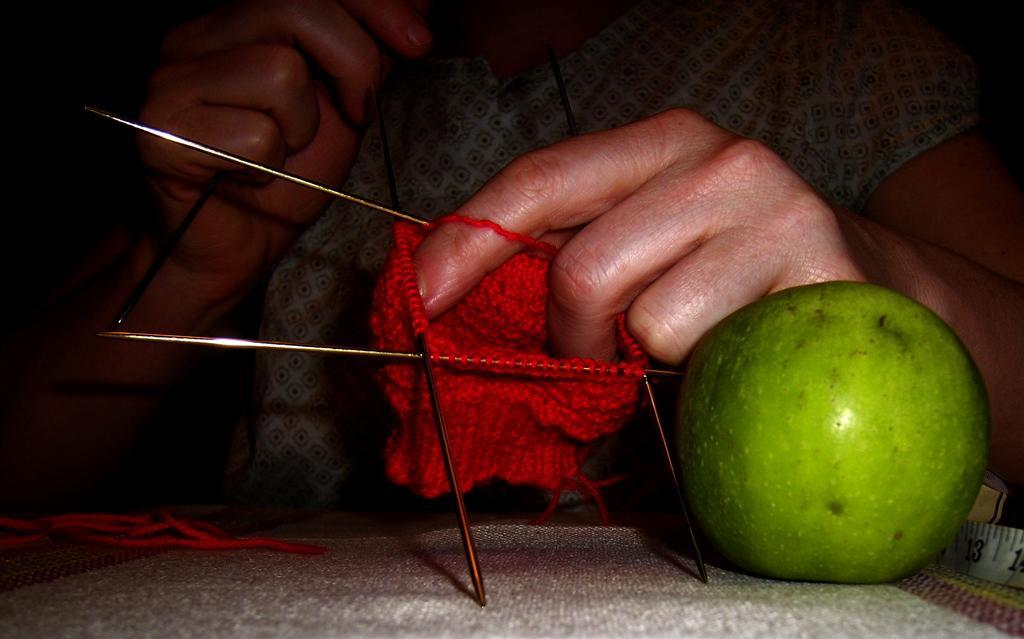Describe this image in one or two sentences. In this image we can see a person doing thread works with needles. Also there is a green color fruit. And we can see a tape. 